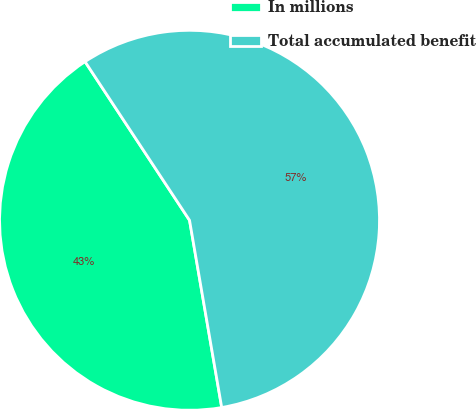Convert chart. <chart><loc_0><loc_0><loc_500><loc_500><pie_chart><fcel>In millions<fcel>Total accumulated benefit<nl><fcel>43.44%<fcel>56.56%<nl></chart> 